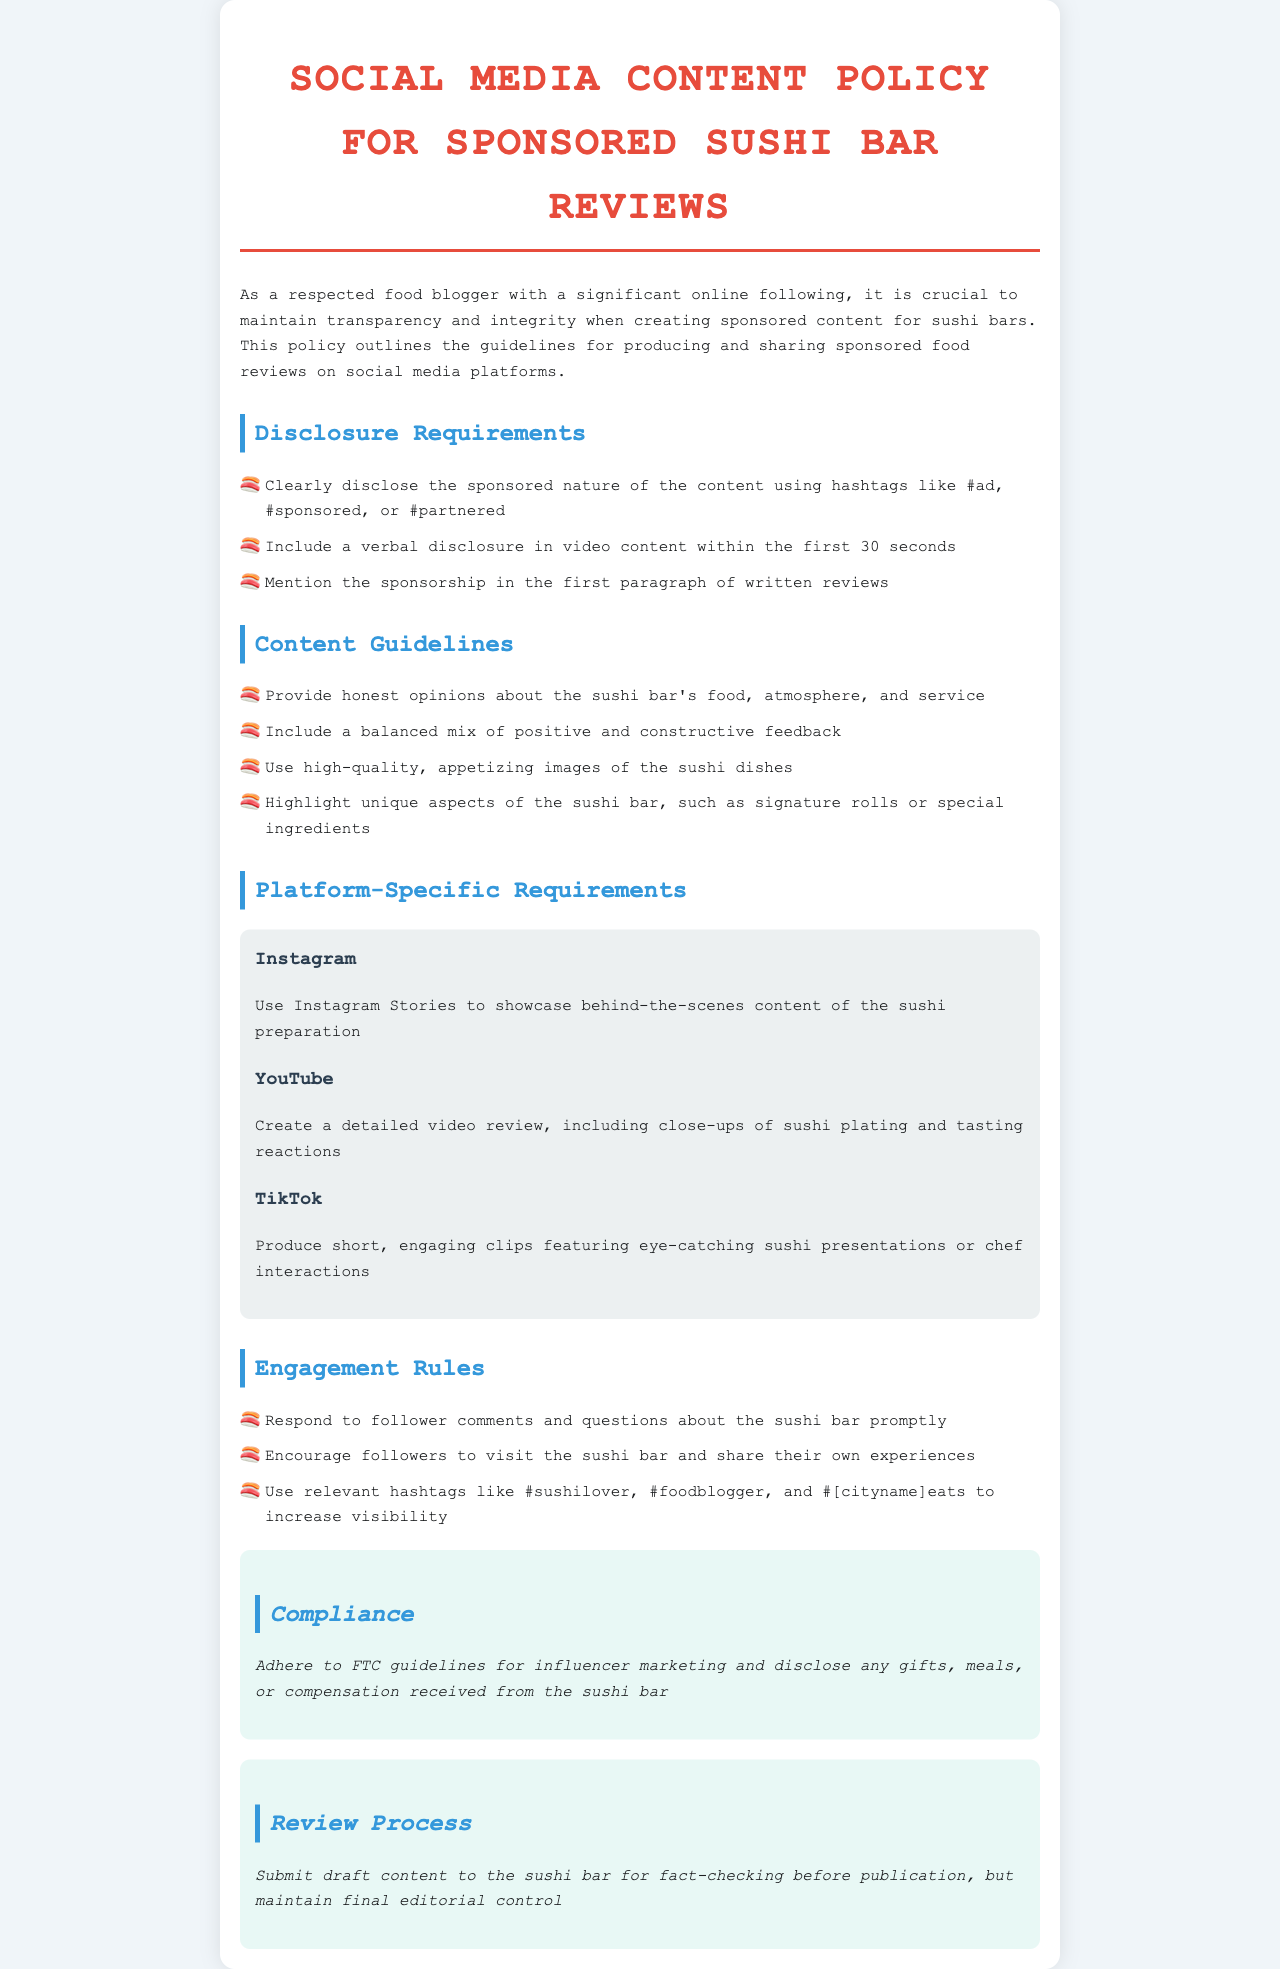What is the document title? The title of the document is stated at the top of the content section, which describes its purpose related to social media content for sushi bar reviews.
Answer: Social Media Content Policy for Sponsored Sushi Bar Reviews What hashtags should be used for disclosure? The document lists acceptable hashtags that indicate sponsorship, which are required for transparency in content.
Answer: #ad, #sponsored, or #partnered How long should the verbal disclosure be in video content? The document specifies the timeframe within which the verbal disclosure should be included, which is crucial for compliance.
Answer: 30 seconds What type of images should be included in content? The guidelines emphasize the importance of visual content and define the quality and nature of images required for the reviews.
Answer: High-quality, appetizing images What should be highlighted about the sushi bar? The document outlines specific aspects that should be emphasized to attract attention and promote unique offerings within the content.
Answer: Unique aspects, such as signature rolls or special ingredients How should follower comments be handled? This reflects the engagement rules defined in the document regarding interaction with the audience on social media platforms.
Answer: Respond promptly What must be submitted to the sushi bar before publication? The review process includes a step that ensures the content's accuracy before it is shared publicly, emphasizing collaboration.
Answer: Draft content What is the primary compliance guideline mentioned? The compliance section addresses legal obligations that must be adhered to when sharing sponsored content on social media.
Answer: FTC guidelines for influencer marketing 